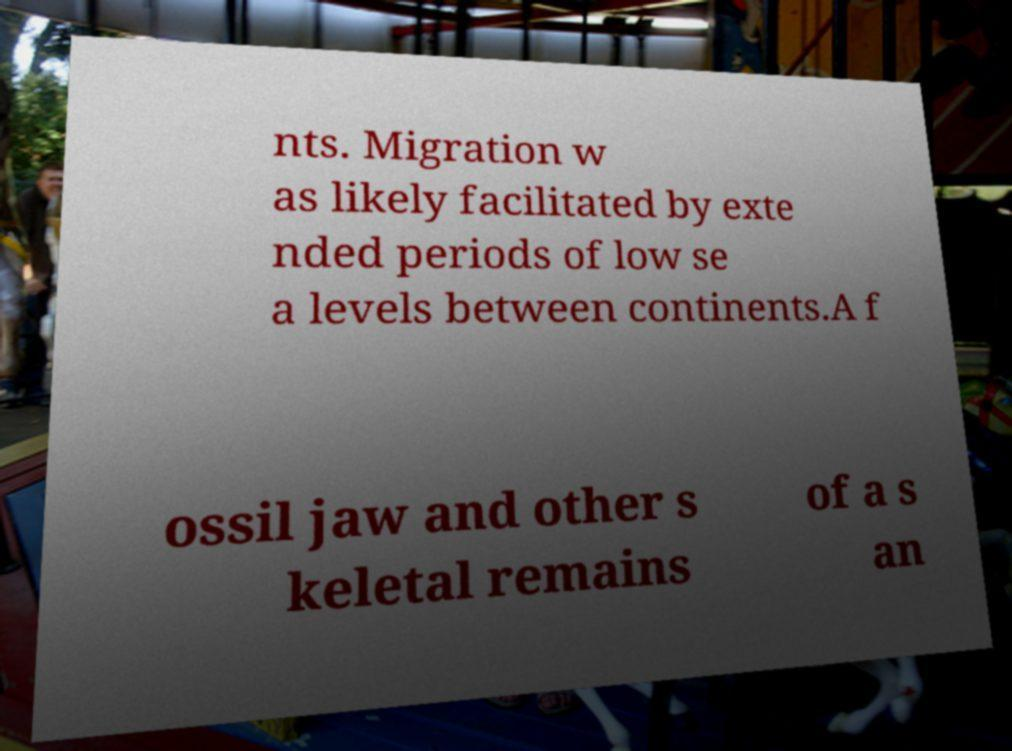Please identify and transcribe the text found in this image. nts. Migration w as likely facilitated by exte nded periods of low se a levels between continents.A f ossil jaw and other s keletal remains of a s an 